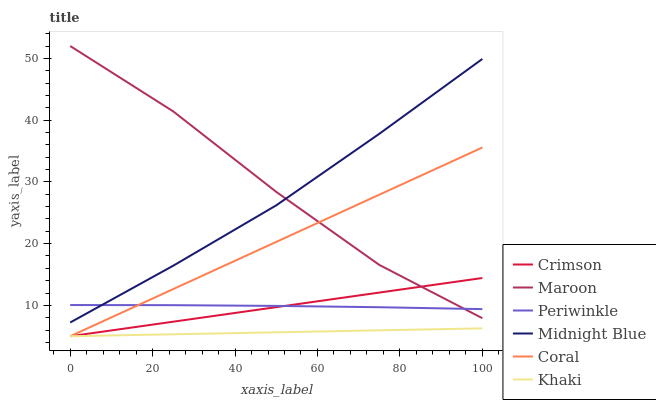Does Khaki have the minimum area under the curve?
Answer yes or no. Yes. Does Maroon have the maximum area under the curve?
Answer yes or no. Yes. Does Midnight Blue have the minimum area under the curve?
Answer yes or no. No. Does Midnight Blue have the maximum area under the curve?
Answer yes or no. No. Is Coral the smoothest?
Answer yes or no. Yes. Is Maroon the roughest?
Answer yes or no. Yes. Is Midnight Blue the smoothest?
Answer yes or no. No. Is Midnight Blue the roughest?
Answer yes or no. No. Does Khaki have the lowest value?
Answer yes or no. Yes. Does Midnight Blue have the lowest value?
Answer yes or no. No. Does Maroon have the highest value?
Answer yes or no. Yes. Does Midnight Blue have the highest value?
Answer yes or no. No. Is Khaki less than Midnight Blue?
Answer yes or no. Yes. Is Periwinkle greater than Khaki?
Answer yes or no. Yes. Does Khaki intersect Coral?
Answer yes or no. Yes. Is Khaki less than Coral?
Answer yes or no. No. Is Khaki greater than Coral?
Answer yes or no. No. Does Khaki intersect Midnight Blue?
Answer yes or no. No. 